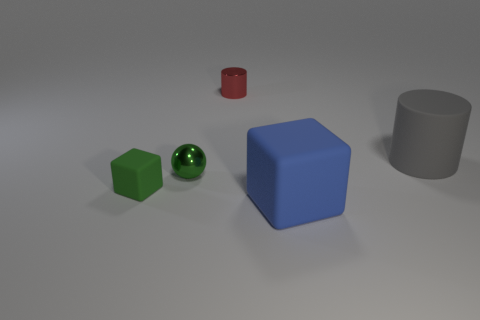What number of metallic cylinders are the same color as the metal ball?
Ensure brevity in your answer.  0. What number of objects are things right of the blue matte object or large blue rubber blocks?
Your answer should be compact. 2. There is a cylinder that is right of the blue rubber object; what size is it?
Ensure brevity in your answer.  Large. Are there fewer balls than brown shiny blocks?
Keep it short and to the point. No. Are the cube on the left side of the large rubber block and the cylinder that is to the left of the large rubber block made of the same material?
Provide a succinct answer. No. There is a green object to the right of the tiny thing that is left of the tiny shiny object in front of the red cylinder; what shape is it?
Provide a succinct answer. Sphere. How many blue cylinders have the same material as the tiny green block?
Offer a very short reply. 0. What number of green objects are to the left of the tiny metal thing in front of the red metal cylinder?
Give a very brief answer. 1. Does the tiny shiny thing to the left of the red thing have the same color as the matte object left of the small red metallic cylinder?
Ensure brevity in your answer.  Yes. What is the shape of the matte thing that is both in front of the big cylinder and on the right side of the small green ball?
Make the answer very short. Cube. 